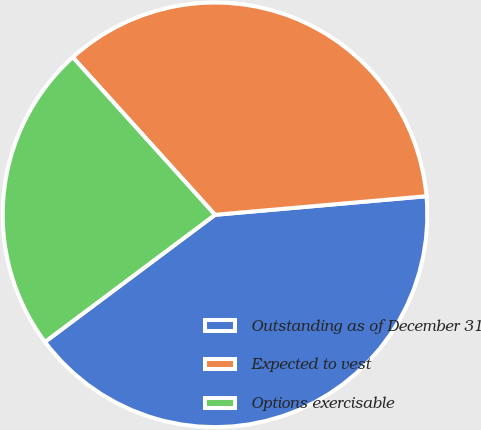Convert chart. <chart><loc_0><loc_0><loc_500><loc_500><pie_chart><fcel>Outstanding as of December 31<fcel>Expected to vest<fcel>Options exercisable<nl><fcel>41.18%<fcel>35.29%<fcel>23.53%<nl></chart> 